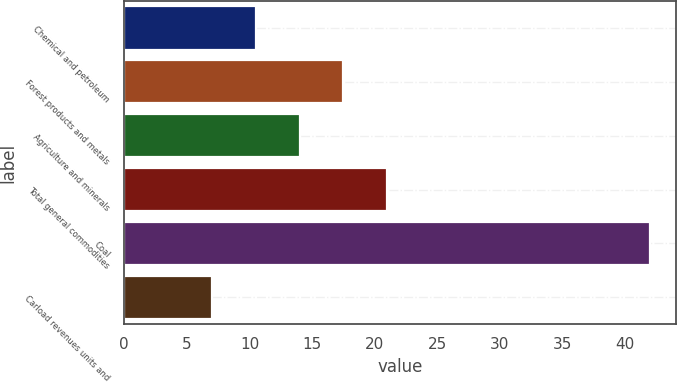Convert chart to OTSL. <chart><loc_0><loc_0><loc_500><loc_500><bar_chart><fcel>Chemical and petroleum<fcel>Forest products and metals<fcel>Agriculture and minerals<fcel>Total general commodities<fcel>Coal<fcel>Carload revenues units and<nl><fcel>10.5<fcel>17.5<fcel>14<fcel>21<fcel>42<fcel>7<nl></chart> 